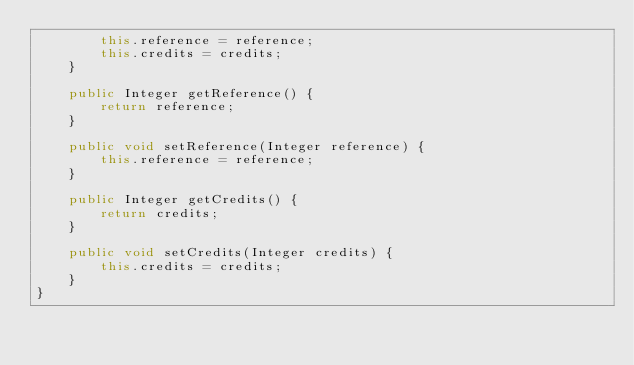<code> <loc_0><loc_0><loc_500><loc_500><_Java_>        this.reference = reference;
        this.credits = credits;
    }

    public Integer getReference() {
        return reference;
    }

    public void setReference(Integer reference) {
        this.reference = reference;
    }

    public Integer getCredits() {
        return credits;
    }

    public void setCredits(Integer credits) {
        this.credits = credits;
    }
}
</code> 